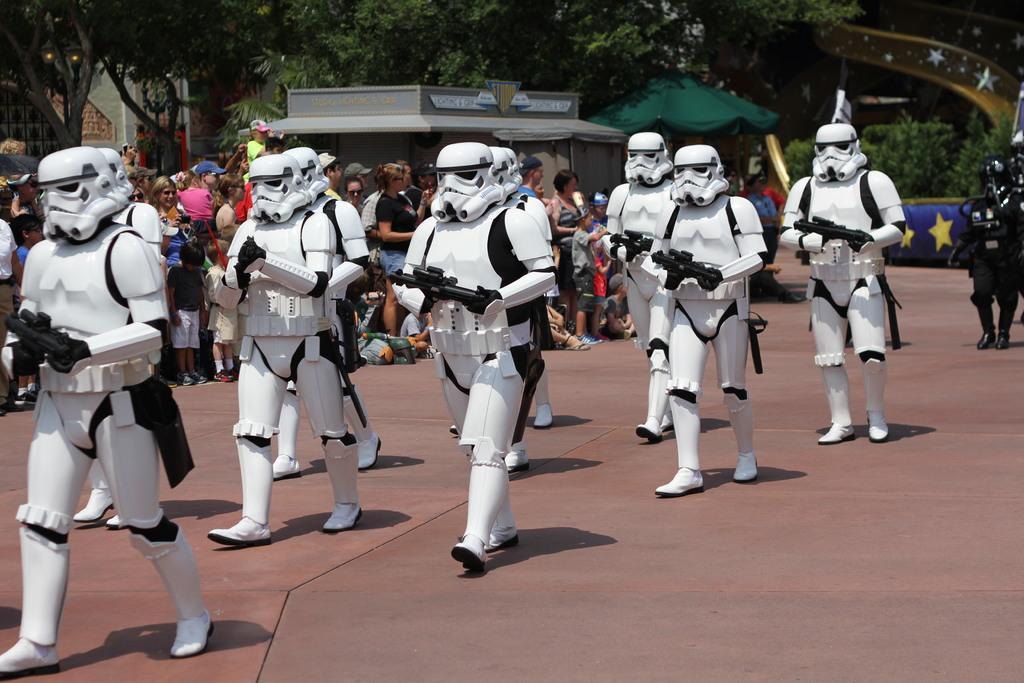Describe this image in one or two sentences. In this image I can see there are group of people holding guns and wearing costumes and back side of the image I can see crowd of people, house , tents , trees. 